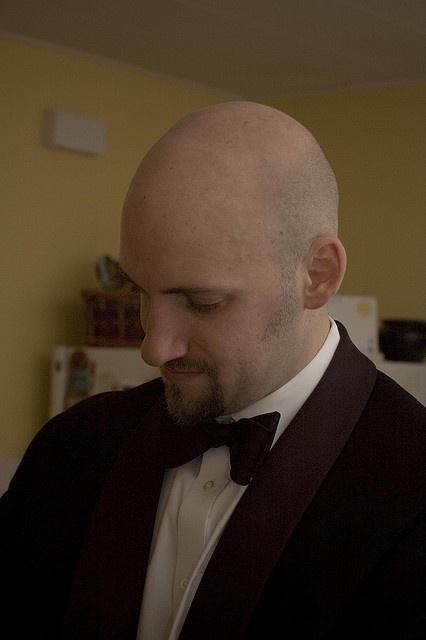Describe the objects in this image and their specific colors. I can see people in black, gray, and maroon tones, refrigerator in black and gray tones, and tie in black and gray tones in this image. 